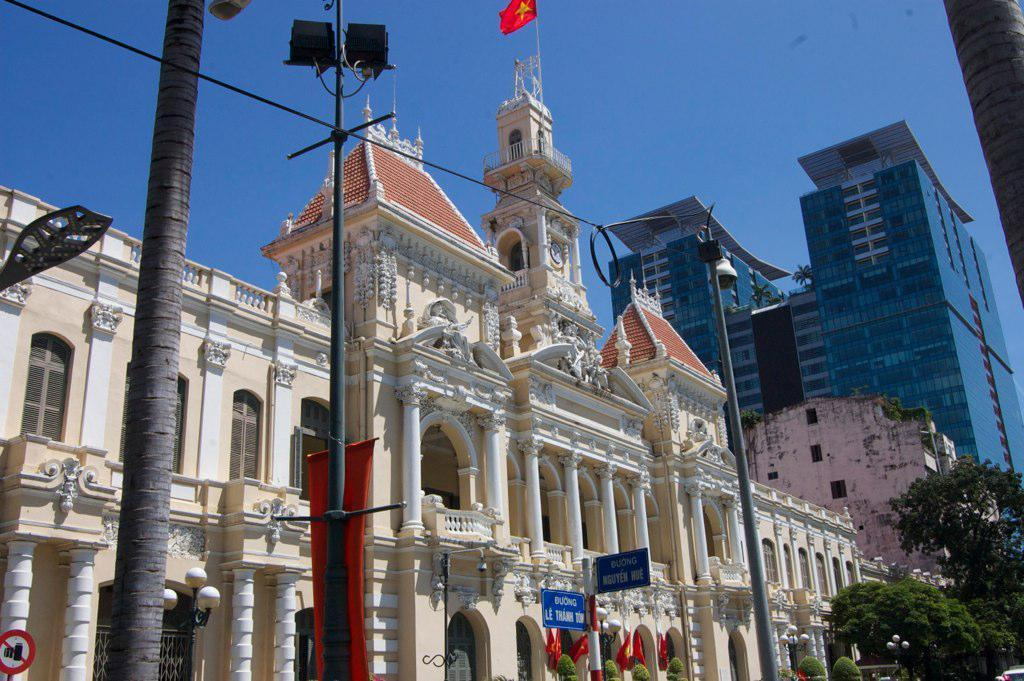What type of structures can be seen in the image? There are buildings in the image. What natural elements are present in the image? There are trees in the image. What are the vertical objects in the image? There are poles in the image. What objects provide information or directions in the image? There are sign boards in the image. What objects provide illumination in the image? There are lights in the image. What large advertising display is present in the image? There is a hoarding in the image. What can be seen at the top of the image? There is a flag at the top of the image. How many yaks are present in the image? There are no yaks present in the image. What type of chalk is used to write on the sign boards in the image? There is no information about the type of chalk used on the sign boards in the image. 